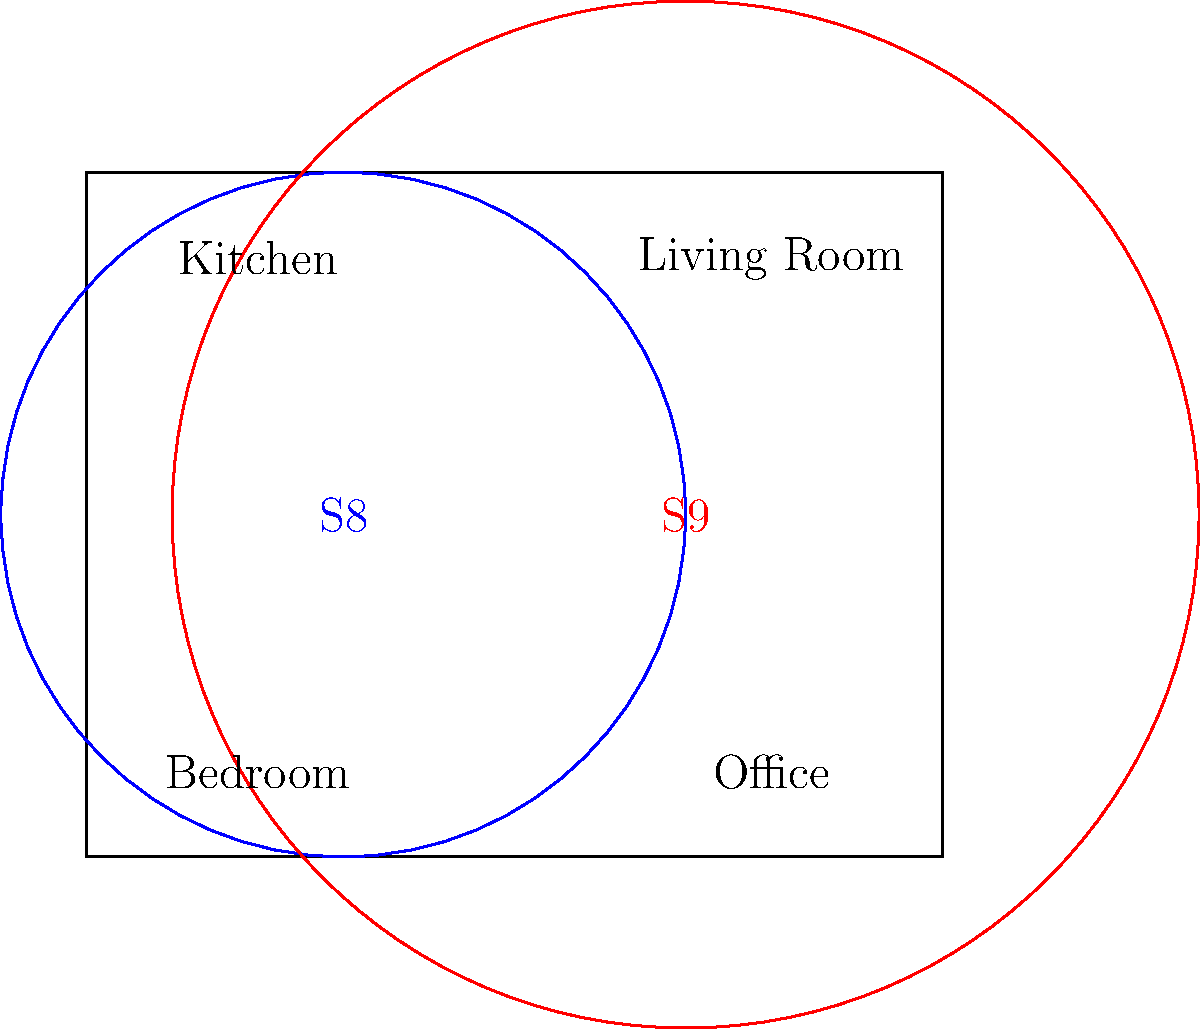Based on the floor plan diagram showing Wi-Fi coverage for the Galaxy Tab S8 (blue) and S9 (red), what percentage increase in coverage area does the S9 provide compared to the S8? To calculate the percentage increase in coverage area:

1. Calculate the area of S8 coverage:
   $A_{S8} = \pi r_{S8}^2 = \pi (40)^2 = 1600\pi$

2. Calculate the area of S9 coverage:
   $A_{S9} = \pi r_{S9}^2 = \pi (60)^2 = 3600\pi$

3. Calculate the difference in area:
   $\Delta A = A_{S9} - A_{S8} = 3600\pi - 1600\pi = 2000\pi$

4. Calculate the percentage increase:
   $\text{Percentage increase} = \frac{\Delta A}{A_{S8}} \times 100\% = \frac{2000\pi}{1600\pi} \times 100\% = 125\%$

The S9 provides a 125% increase in coverage area compared to the S8.
Answer: 125% 